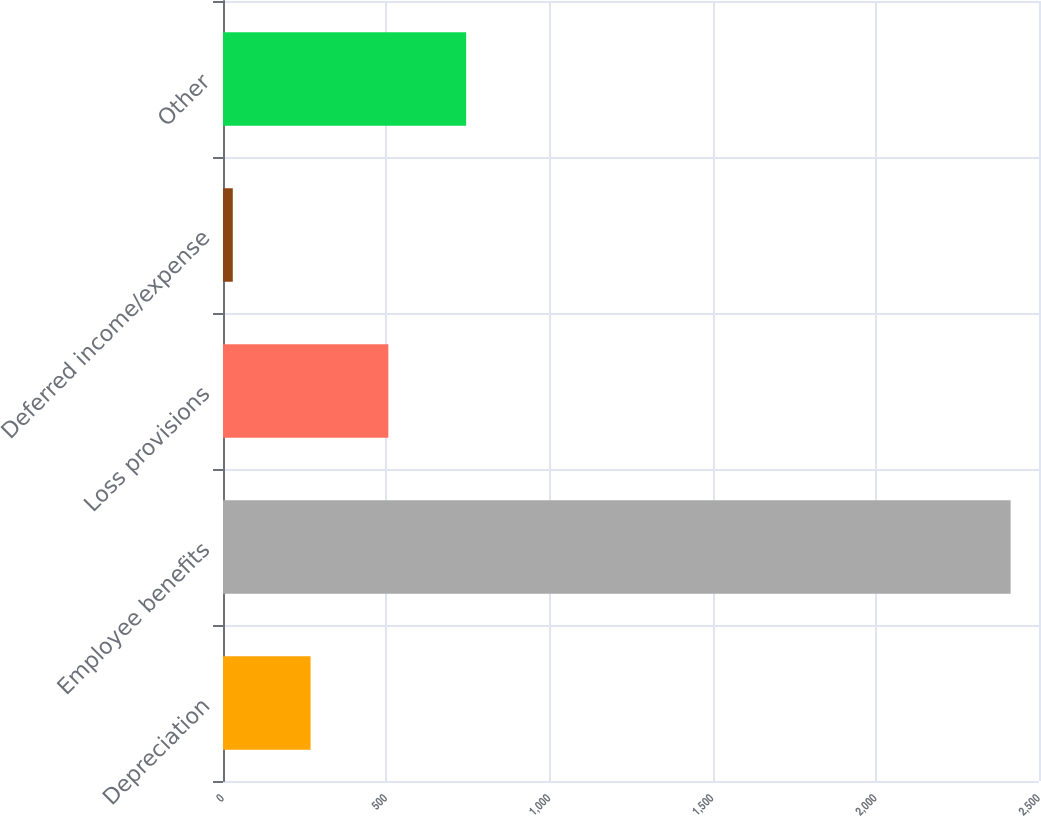Convert chart to OTSL. <chart><loc_0><loc_0><loc_500><loc_500><bar_chart><fcel>Depreciation<fcel>Employee benefits<fcel>Loss provisions<fcel>Deferred income/expense<fcel>Other<nl><fcel>268.3<fcel>2413<fcel>506.6<fcel>30<fcel>744.9<nl></chart> 